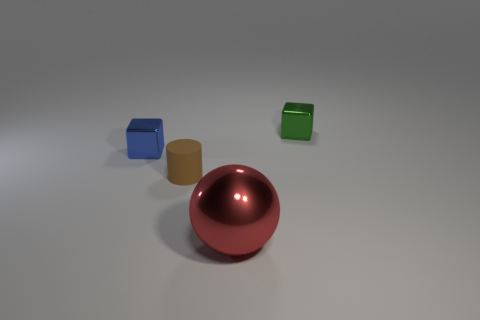Are these objects arranged in a specific pattern? They appear to be randomly placed, without a clear pattern, symbolizing perhaps a natural, unforced arrangement that could relate to the randomness of items in a space. Could the spacing between the objects suggest anything about their relationship? The spacing might suggest that each object stands alone, with its own space and presence, yet their proximity also suggests a possible interaction or connection, despite their differences. 